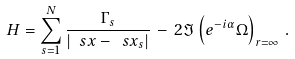<formula> <loc_0><loc_0><loc_500><loc_500>H = \sum _ { s = 1 } ^ { N } \frac { \Gamma _ { s } } { | \ s x - \ s x _ { s } | } \, - \, 2 \Im \left ( e ^ { - i \alpha } \Omega \right ) _ { r = \infty } \, .</formula> 